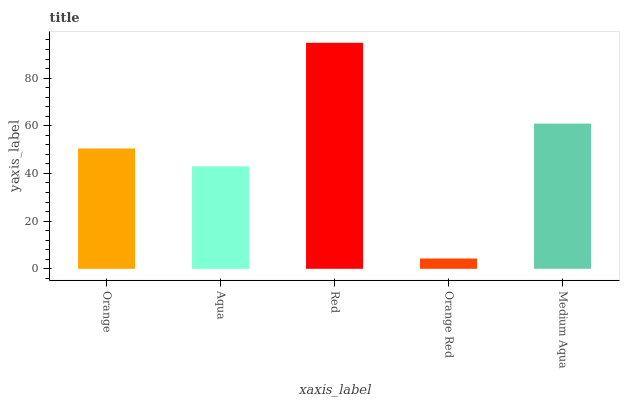Is Orange Red the minimum?
Answer yes or no. Yes. Is Red the maximum?
Answer yes or no. Yes. Is Aqua the minimum?
Answer yes or no. No. Is Aqua the maximum?
Answer yes or no. No. Is Orange greater than Aqua?
Answer yes or no. Yes. Is Aqua less than Orange?
Answer yes or no. Yes. Is Aqua greater than Orange?
Answer yes or no. No. Is Orange less than Aqua?
Answer yes or no. No. Is Orange the high median?
Answer yes or no. Yes. Is Orange the low median?
Answer yes or no. Yes. Is Aqua the high median?
Answer yes or no. No. Is Aqua the low median?
Answer yes or no. No. 